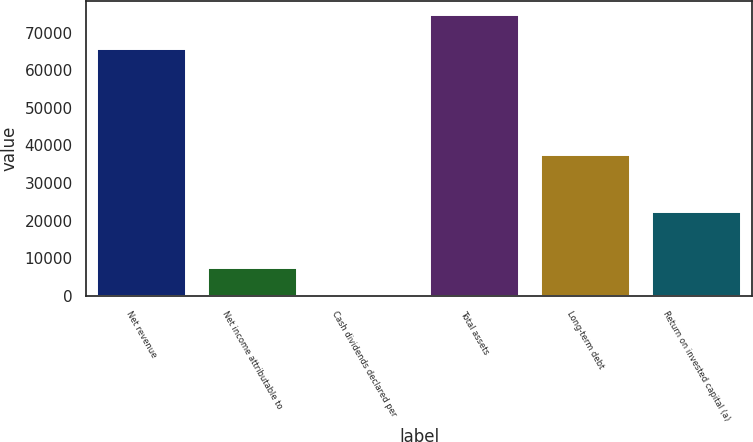Convert chart. <chart><loc_0><loc_0><loc_500><loc_500><bar_chart><fcel>Net revenue<fcel>Net income attributable to<fcel>Cash dividends declared per<fcel>Total assets<fcel>Long-term debt<fcel>Return on invested capital (a)<nl><fcel>65492<fcel>7465.72<fcel>2.13<fcel>74638<fcel>37320.1<fcel>22392.9<nl></chart> 